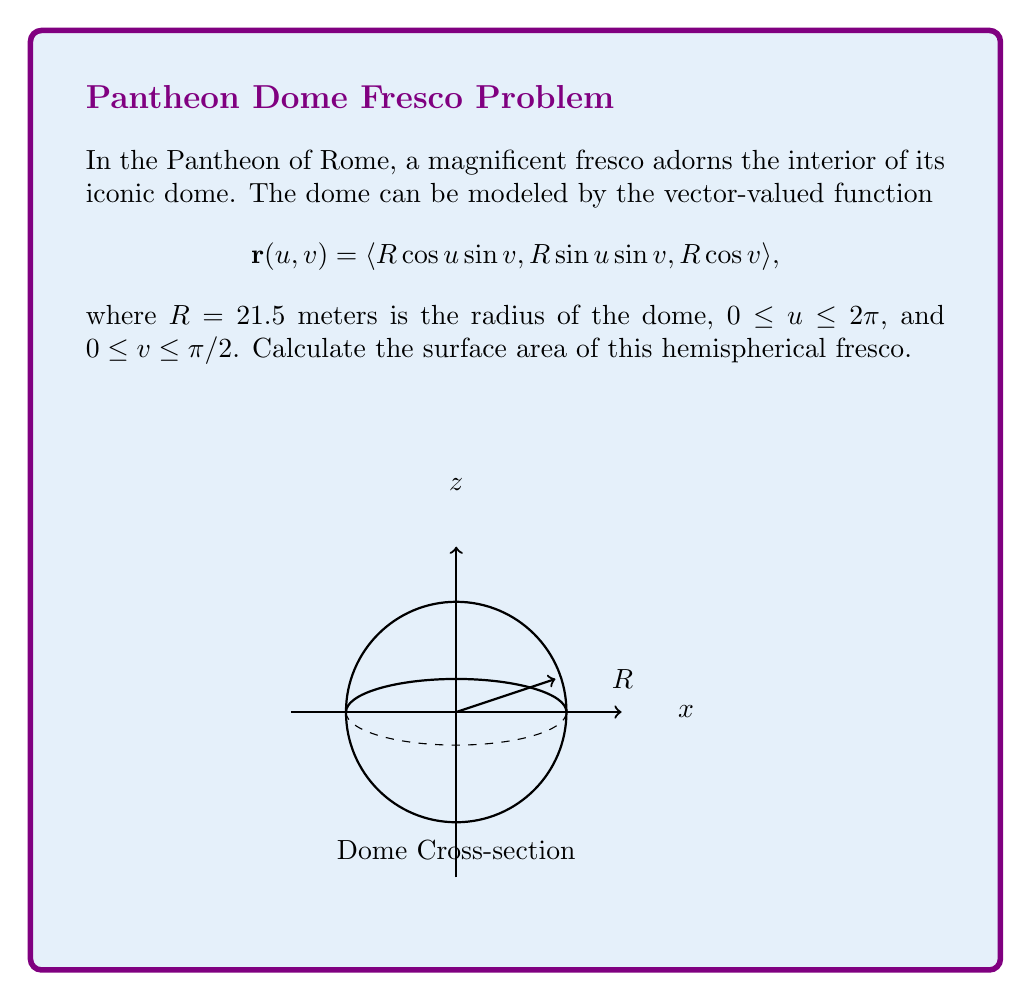What is the answer to this math problem? To calculate the surface area of the hemispherical fresco, we'll follow these steps:

1) For a surface defined by a vector-valued function $\mathbf{r}(u,v)$, the surface area is given by the double integral:

   $$ A = \int\int_D \|\mathbf{r}_u \times \mathbf{r}_v\| \,du\,dv $$

   where $\mathbf{r}_u$ and $\mathbf{r}_v$ are partial derivatives with respect to $u$ and $v$.

2) Calculate $\mathbf{r}_u$ and $\mathbf{r}_v$:
   $$ \mathbf{r}_u = \langle -R\sin u \sin v, R\cos u \sin v, 0 \rangle $$
   $$ \mathbf{r}_v = \langle R\cos u \cos v, R\sin u \cos v, -R\sin v \rangle $$

3) Calculate the cross product $\mathbf{r}_u \times \mathbf{r}_v$:
   $$ \mathbf{r}_u \times \mathbf{r}_v = \langle R^2\cos u \sin^2 v, R^2\sin u \sin^2 v, R^2\sin v \cos v \rangle $$

4) Calculate the magnitude of the cross product:
   $$ \|\mathbf{r}_u \times \mathbf{r}_v\| = R^2\sin v $$

5) Set up the double integral:
   $$ A = \int_0^{2\pi} \int_0^{\pi/2} R^2\sin v \,dv\,du $$

6) Evaluate the integral:
   $$ A = R^2 \int_0^{2\pi} \left[-\cos v\right]_0^{\pi/2} \,du = R^2 \int_0^{2\pi} 1 \,du = 2\pi R^2 $$

7) Substitute $R = 21.5$ meters:
   $$ A = 2\pi (21.5)^2 \approx 2,895.31 \text{ m}^2 $$
Answer: $2\pi R^2 \approx 2,895.31 \text{ m}^2$ 